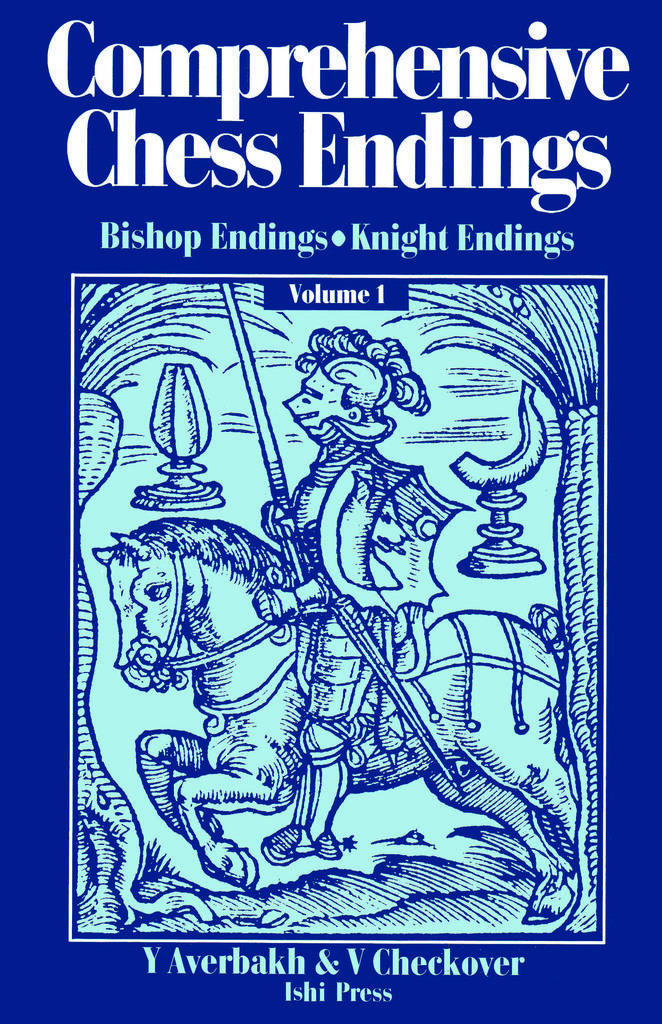What is the title of this book?
Your answer should be compact. Comprehensive chess endings. Who is the author of the book?
Keep it short and to the point. Y averbakh & v checkover. 